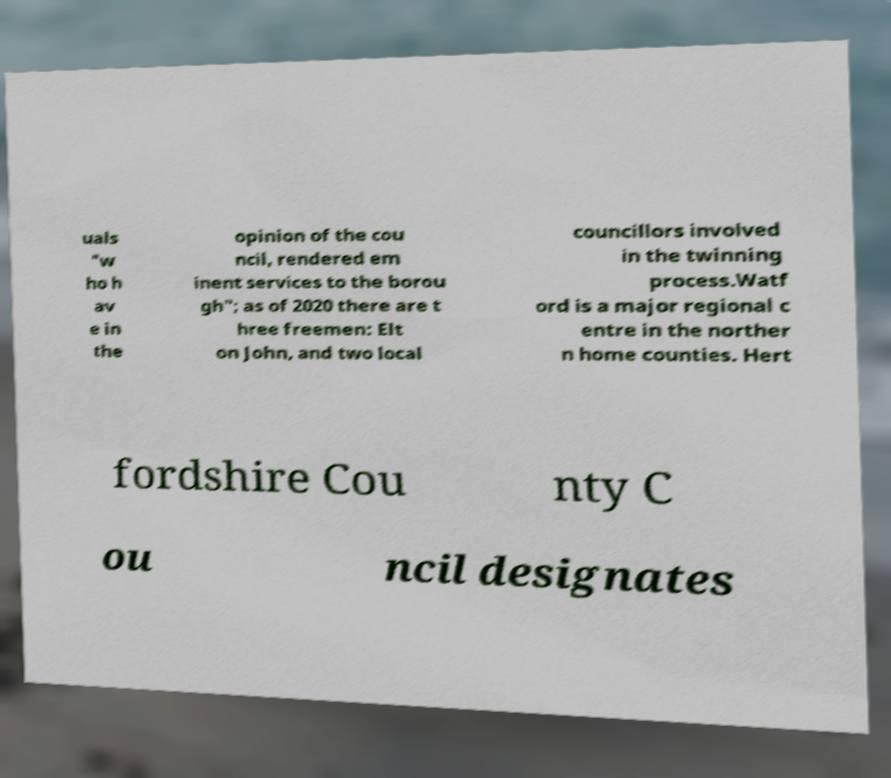What messages or text are displayed in this image? I need them in a readable, typed format. uals "w ho h av e in the opinion of the cou ncil, rendered em inent services to the borou gh"; as of 2020 there are t hree freemen: Elt on John, and two local councillors involved in the twinning process.Watf ord is a major regional c entre in the norther n home counties. Hert fordshire Cou nty C ou ncil designates 